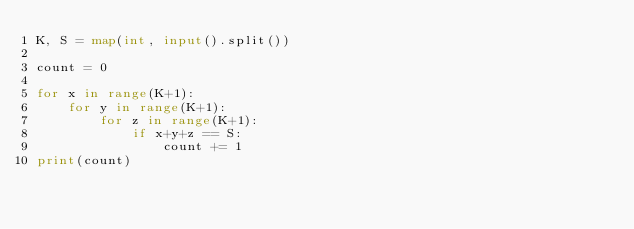Convert code to text. <code><loc_0><loc_0><loc_500><loc_500><_Python_>K, S = map(int, input().split())

count = 0

for x in range(K+1):
    for y in range(K+1):
        for z in range(K+1):
            if x+y+z == S:
                count += 1
print(count)</code> 